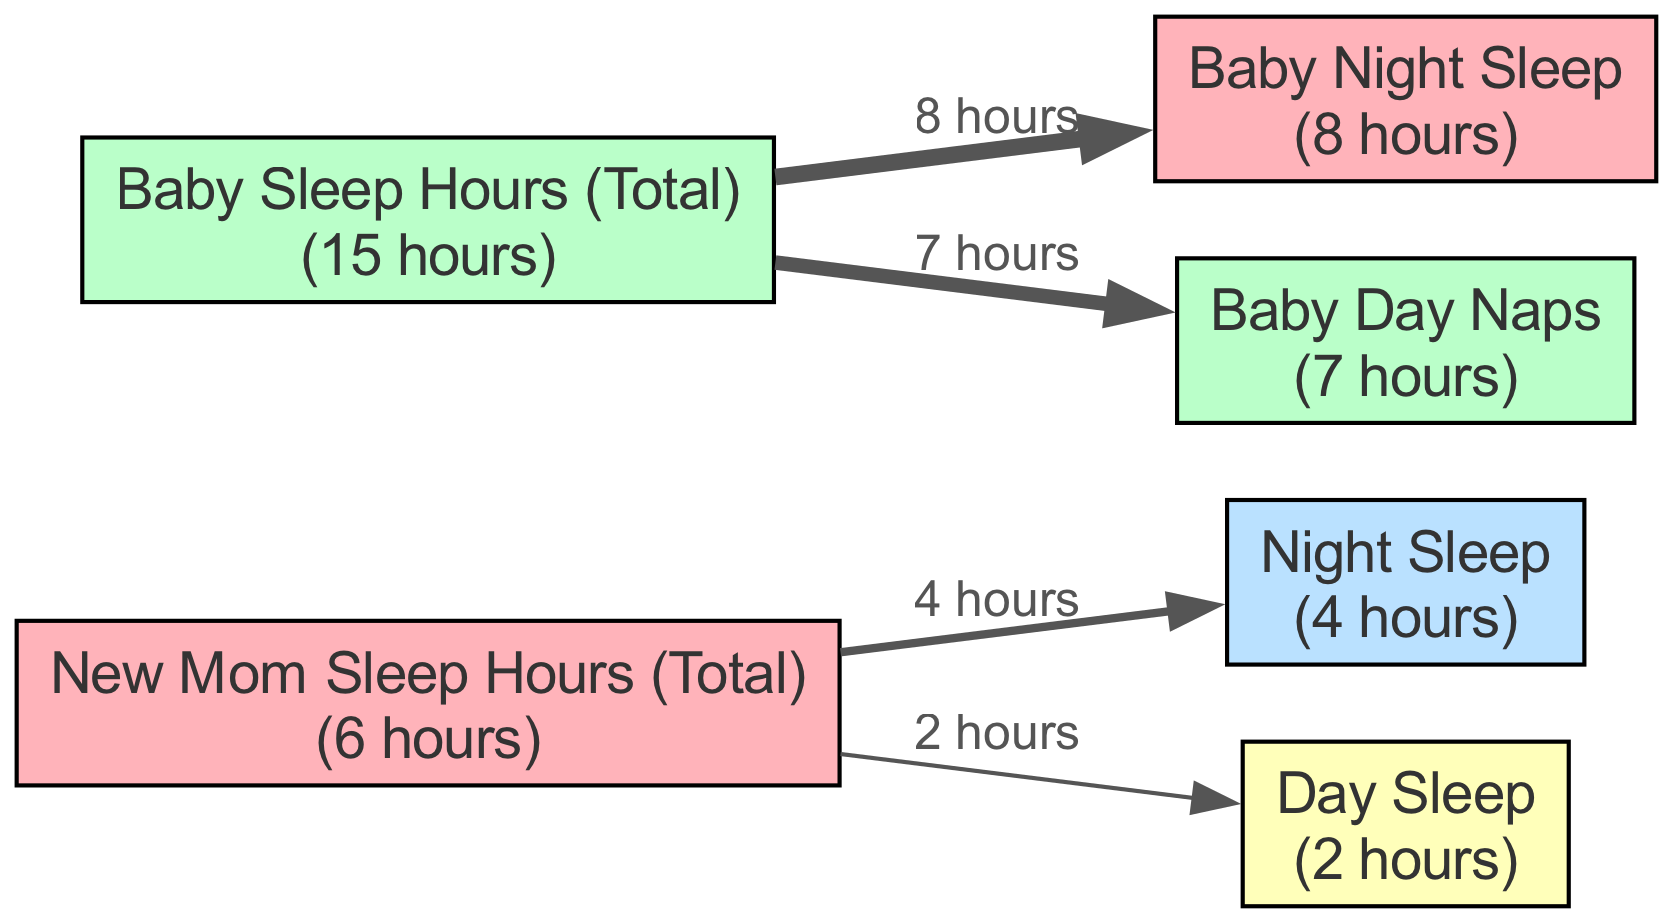What is the total sleep hours for the new mom? The diagram indicates a specific node labeled "New Mom Sleep Hours (Total)" with a value of 6 hours. This directly signifies the total amount of sleep hours the new mom has.
Answer: 6 What are the total sleep hours for the baby? The diagram includes a node labeled "Baby Sleep Hours (Total)" with a value of 15 hours, indicating the total sleep hours the baby accumulates throughout the day.
Answer: 15 How many hours does the new mom sleep at night? The diagram shows that the "Night Sleep" node under "New Mom Sleep Hours" has a value of 4 hours. This reflects the number of hours the new mom sleeps during the night.
Answer: 4 How many hours does the baby sleep at night? According to the diagram, under the "Baby Sleep Hours" node, the "Baby Night Sleep" has a value of 8 hours, which indicates the duration the baby sleeps at night.
Answer: 8 What is the difference in total sleep hours between the baby and the new mom? To find the difference, we subtract the new mom's total sleep hours (6) from the baby's total sleep hours (15). So, 15 - 6 equals 9 hours.
Answer: 9 How many total sleep hours does the baby take during the day? The diagram indicates that the "Baby Day Naps" node has a value of 7 hours, which reflects the total duration that the baby sleeps during the day.
Answer: 7 Is the baby getting more sleep than the new mom both during the night and the day combined? The baby sleeps a total of 15 hours (8 at night and 7 during the day) while the new mom only gets 6 hours (4 at night and 2 during the day). Thus, the baby is getting more sleep overall.
Answer: Yes What proportion of the new mom's sleep is during the night? The new mom sleeps for 4 hours at night out of 6 total hours, so to determine the proportion, we divide 4 by 6, resulting in approximately 0.67 or 67%.
Answer: 67% What percentage of the baby's sleep is made up by day naps? The baby takes 7 hours of day naps out of a total of 15 hours, so we calculate the percentage by dividing 7 by 15, which results in approximately 0.47 or 47%.
Answer: 47% 